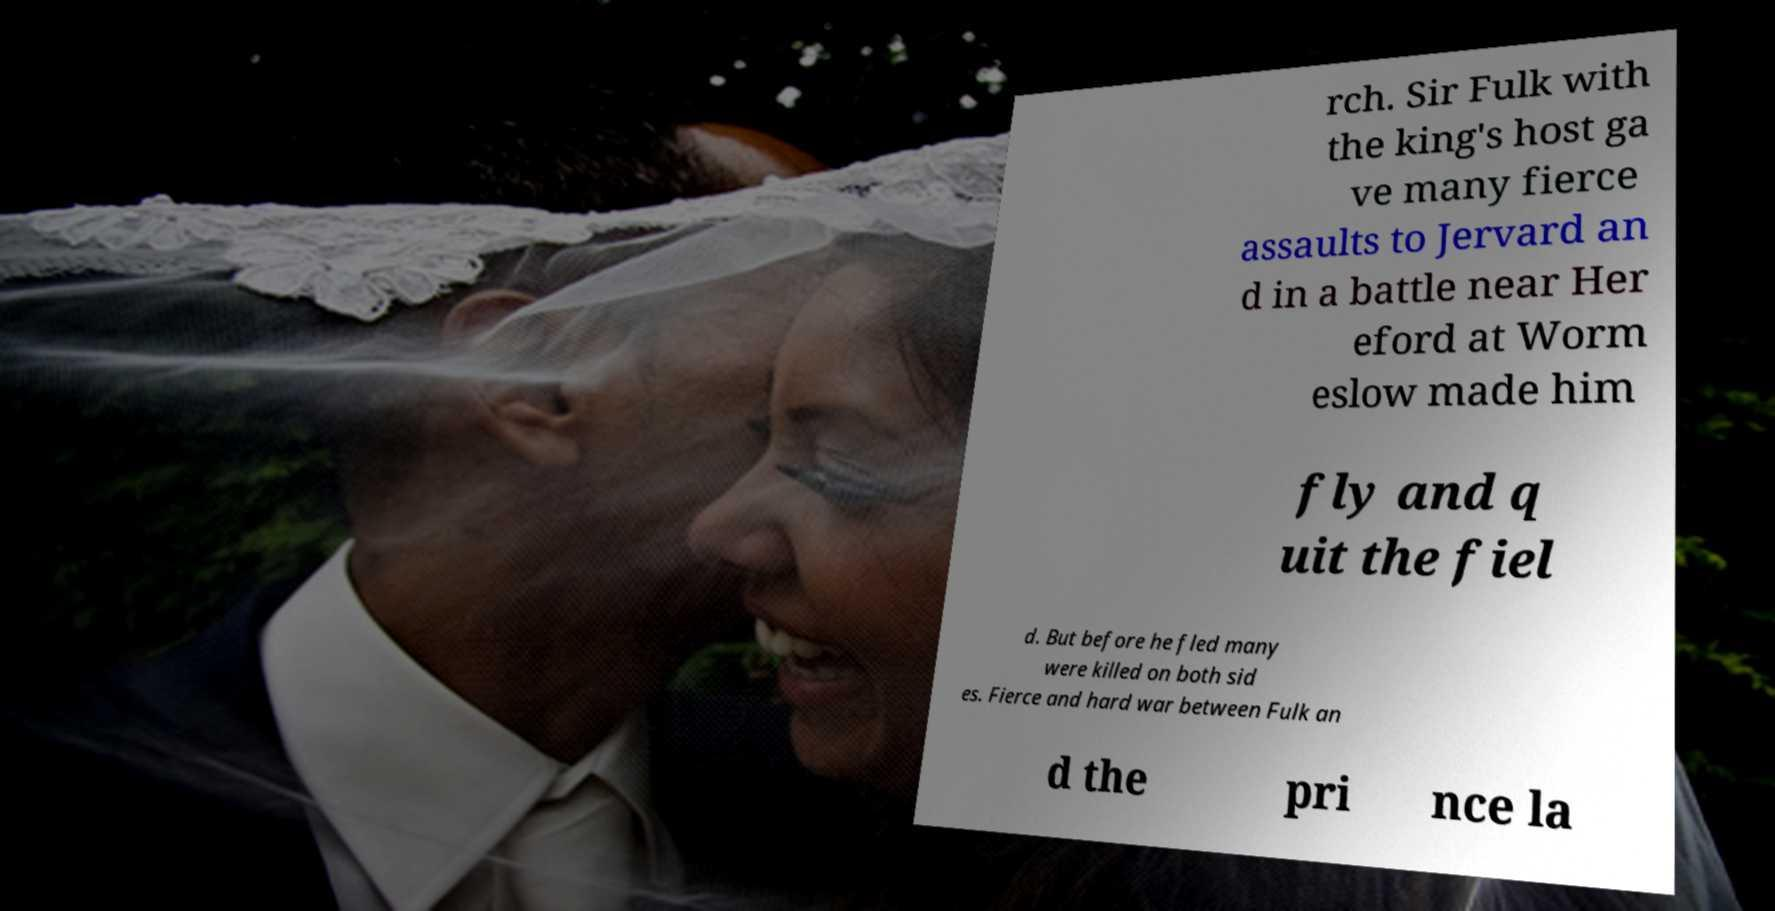Could you assist in decoding the text presented in this image and type it out clearly? rch. Sir Fulk with the king's host ga ve many fierce assaults to Jervard an d in a battle near Her eford at Worm eslow made him fly and q uit the fiel d. But before he fled many were killed on both sid es. Fierce and hard war between Fulk an d the pri nce la 